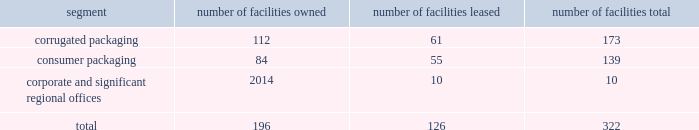Consume significant amounts of energy , and we may in the future incur additional or increased capital , operating and other expenditures from changes due to new or increased climate-related and other environmental regulations .
We could also incur substantial liabilities , including fines or sanctions , enforcement actions , natural resource damages claims , cleanup and closure costs , and third-party claims for property damage and personal injury under environmental and common laws .
The foreign corrupt practices act of 1977 and local anti-bribery laws , including those in brazil , china , mexico , india and the united kingdom ( where we maintain operations directly or through a joint venture ) , prohibit companies and their intermediaries from making improper payments to government officials for the purpose of influencing official decisions .
Our internal control policies and procedures , or those of our vendors , may not adequately protect us from reckless or criminal acts committed or alleged to have been committed by our employees , agents or vendors .
Any such violations could lead to civil or criminal monetary and non-monetary penalties and/or could damage our reputation .
We are subject to a number of labor and employment laws and regulations that could significantly increase our operating costs and reduce our operational flexibility .
Additionally , changing privacy laws in the united states ( including the california consumer privacy act , which will become effective in january 2020 ) , europe ( where the general data protection regulation became effective in 2018 ) and elsewhere have created new individual privacy rights , imposed increased obligations on companies handling personal data and increased potential exposure to fines and penalties .
Item 1b .
Unresolved staff comments there are no unresolved sec staff comments .
Item 2 .
Properties we operate locations in north america , including the majority of u.s .
States , south america , europe , asia and australia .
We lease our principal offices in atlanta , ga .
We believe that our existing production capacity is adequate to serve existing demand for our products and consider our plants and equipment to be in good condition .
Our corporate and operating facilities as of september 30 , 2019 are summarized below: .
The tables that follow show our annual production capacity by mill at september 30 , 2019 in thousands of tons , except for the north charleston , sc mill which reflects our capacity after the previously announced machine closure expected to occur in fiscal 2020 .
Our mill system production levels and operating rates may vary from year to year due to changes in market and other factors , including the impact of hurricanes and other weather-related events .
Our simple average mill system operating rates for the last three years averaged 94% ( 94 % ) .
We own all of our mills. .
What percent of facilities are owned by the company? 
Rationale: would've liked to do something with the mill capacity/operating margins but that data not included
Computations: (196 / 322)
Answer: 0.6087. 